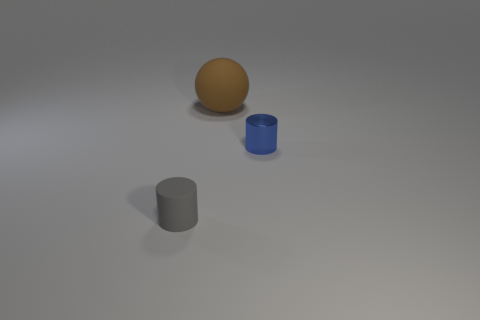How big is the rubber sphere?
Provide a succinct answer. Large. There is a object that is left of the rubber thing that is on the right side of the gray matte object; what is its color?
Provide a short and direct response. Gray. Is there anything else that has the same size as the brown rubber ball?
Ensure brevity in your answer.  No. Is the shape of the small object that is in front of the blue metal thing the same as  the blue object?
Offer a terse response. Yes. What number of small things are both to the left of the brown rubber object and behind the gray matte cylinder?
Ensure brevity in your answer.  0. What color is the object in front of the small object that is to the right of the object that is in front of the small blue cylinder?
Make the answer very short. Gray. There is a thing that is to the left of the large ball; how many cylinders are behind it?
Provide a succinct answer. 1. How many other objects are there of the same shape as the big brown object?
Your answer should be compact. 0. What number of objects are small green rubber things or cylinders behind the tiny gray cylinder?
Offer a terse response. 1. Are there more cylinders right of the gray matte cylinder than large rubber spheres that are right of the blue metal cylinder?
Provide a short and direct response. Yes. 